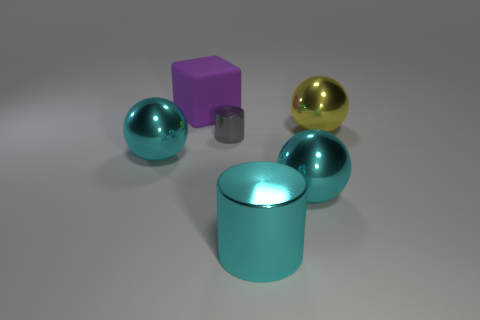Subtract all cyan balls. How many balls are left? 1 Subtract all cylinders. How many objects are left? 4 Subtract all yellow balls. How many balls are left? 2 Subtract all brown spheres. Subtract all big purple cubes. How many objects are left? 5 Add 1 yellow balls. How many yellow balls are left? 2 Add 2 large brown balls. How many large brown balls exist? 2 Add 3 purple shiny blocks. How many objects exist? 9 Subtract 0 yellow cylinders. How many objects are left? 6 Subtract 1 cylinders. How many cylinders are left? 1 Subtract all blue cylinders. Subtract all yellow spheres. How many cylinders are left? 2 